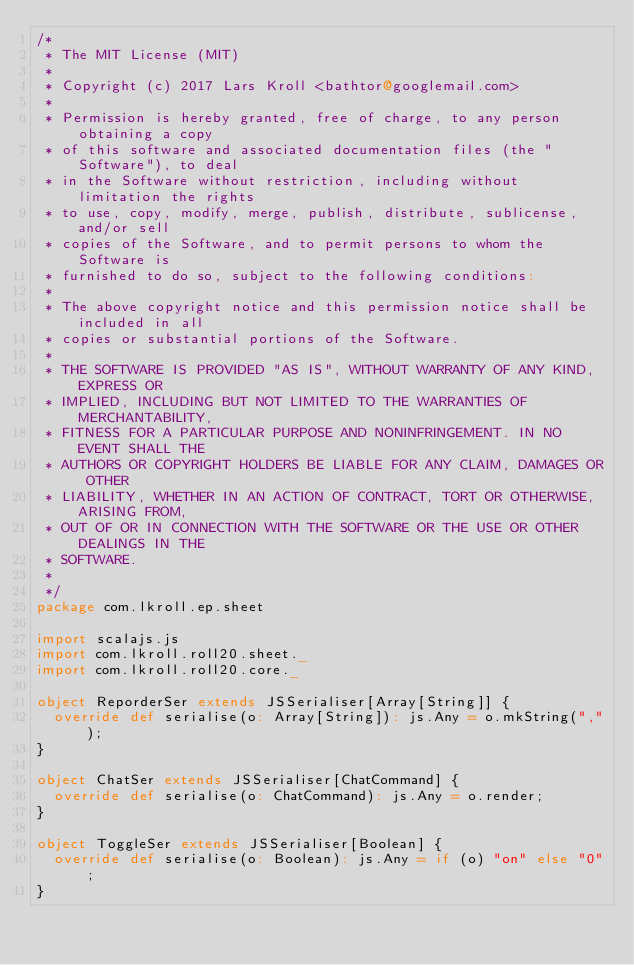Convert code to text. <code><loc_0><loc_0><loc_500><loc_500><_Scala_>/*
 * The MIT License (MIT)
 *
 * Copyright (c) 2017 Lars Kroll <bathtor@googlemail.com>
 *
 * Permission is hereby granted, free of charge, to any person obtaining a copy
 * of this software and associated documentation files (the "Software"), to deal
 * in the Software without restriction, including without limitation the rights
 * to use, copy, modify, merge, publish, distribute, sublicense, and/or sell
 * copies of the Software, and to permit persons to whom the Software is
 * furnished to do so, subject to the following conditions:
 *
 * The above copyright notice and this permission notice shall be included in all
 * copies or substantial portions of the Software.
 *
 * THE SOFTWARE IS PROVIDED "AS IS", WITHOUT WARRANTY OF ANY KIND, EXPRESS OR
 * IMPLIED, INCLUDING BUT NOT LIMITED TO THE WARRANTIES OF MERCHANTABILITY,
 * FITNESS FOR A PARTICULAR PURPOSE AND NONINFRINGEMENT. IN NO EVENT SHALL THE
 * AUTHORS OR COPYRIGHT HOLDERS BE LIABLE FOR ANY CLAIM, DAMAGES OR OTHER
 * LIABILITY, WHETHER IN AN ACTION OF CONTRACT, TORT OR OTHERWISE, ARISING FROM,
 * OUT OF OR IN CONNECTION WITH THE SOFTWARE OR THE USE OR OTHER DEALINGS IN THE
 * SOFTWARE.
 *
 */
package com.lkroll.ep.sheet

import scalajs.js
import com.lkroll.roll20.sheet._
import com.lkroll.roll20.core._

object ReporderSer extends JSSerialiser[Array[String]] {
  override def serialise(o: Array[String]): js.Any = o.mkString(",");
}

object ChatSer extends JSSerialiser[ChatCommand] {
  override def serialise(o: ChatCommand): js.Any = o.render;
}

object ToggleSer extends JSSerialiser[Boolean] {
  override def serialise(o: Boolean): js.Any = if (o) "on" else "0";
}
</code> 